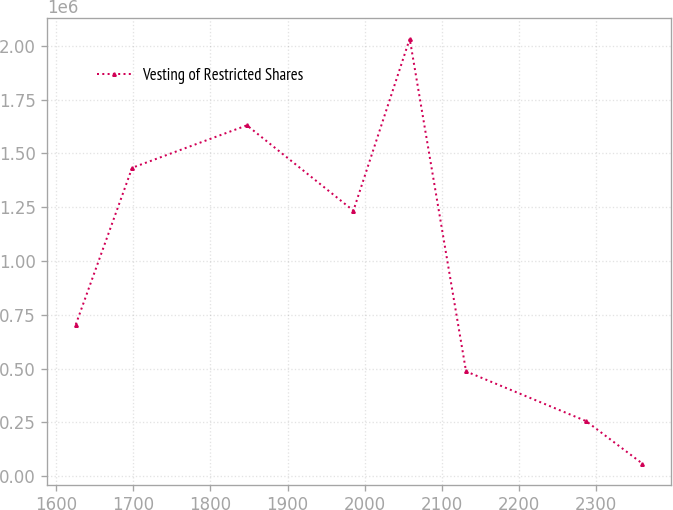Convert chart. <chart><loc_0><loc_0><loc_500><loc_500><line_chart><ecel><fcel>Vesting of Restricted Shares<nl><fcel>1625.38<fcel>704829<nl><fcel>1698.42<fcel>1.43301e+06<nl><fcel>1847.26<fcel>1.63041e+06<nl><fcel>1985.32<fcel>1.23388e+06<nl><fcel>2058.36<fcel>2.03268e+06<nl><fcel>2131.39<fcel>487044<nl><fcel>2286.95<fcel>256134<nl><fcel>2359.98<fcel>58740.2<nl></chart> 